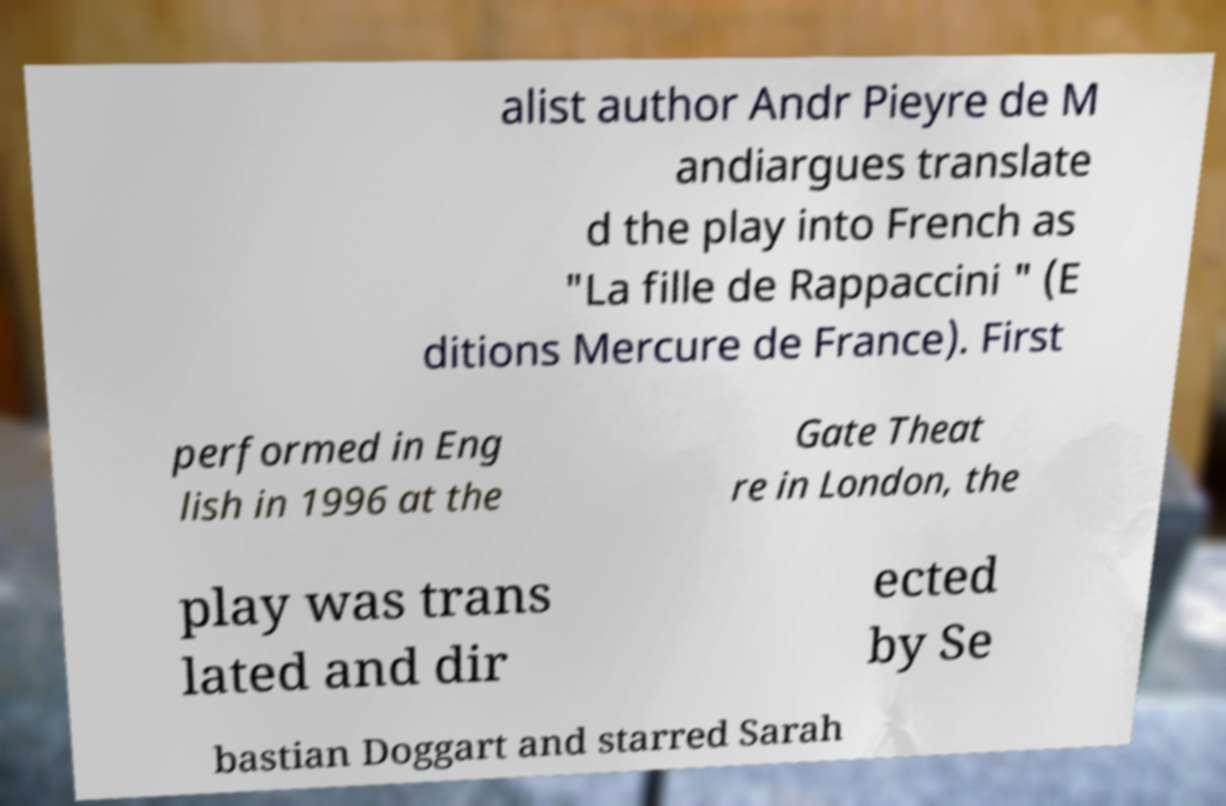For documentation purposes, I need the text within this image transcribed. Could you provide that? alist author Andr Pieyre de M andiargues translate d the play into French as "La fille de Rappaccini " (E ditions Mercure de France). First performed in Eng lish in 1996 at the Gate Theat re in London, the play was trans lated and dir ected by Se bastian Doggart and starred Sarah 